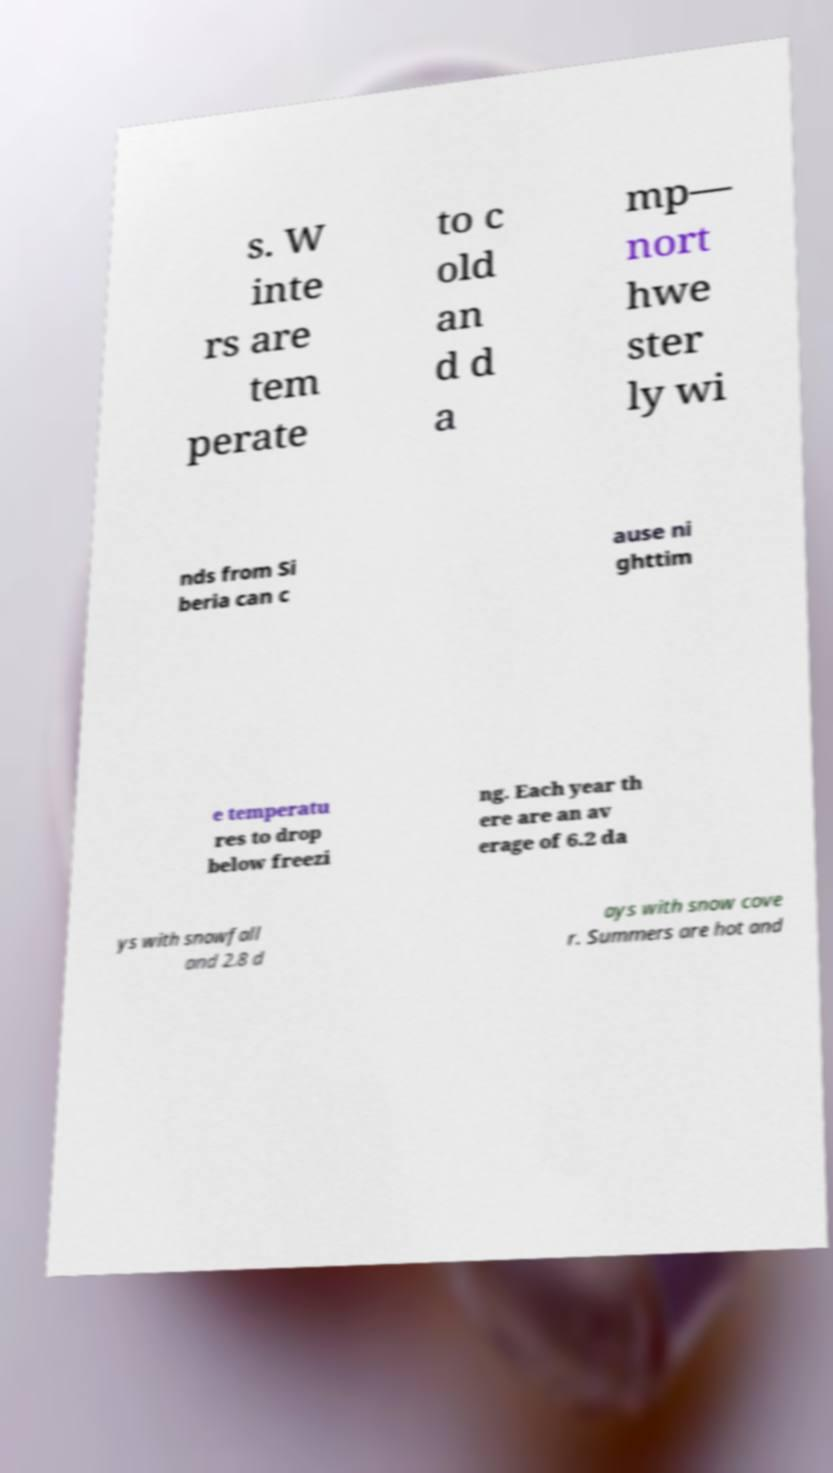Please read and relay the text visible in this image. What does it say? s. W inte rs are tem perate to c old an d d a mp— nort hwe ster ly wi nds from Si beria can c ause ni ghttim e temperatu res to drop below freezi ng. Each year th ere are an av erage of 6.2 da ys with snowfall and 2.8 d ays with snow cove r. Summers are hot and 